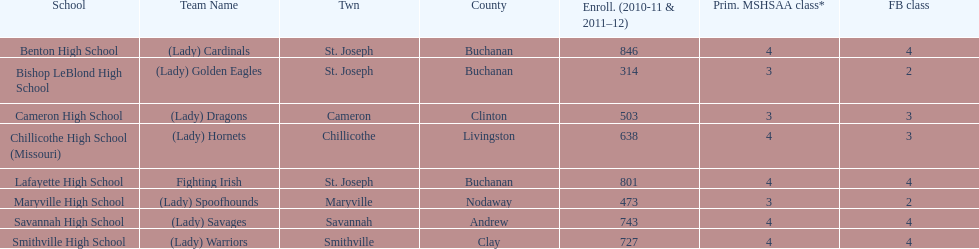What school has 3 football classes but only has 638 student enrollment? Chillicothe High School (Missouri). 